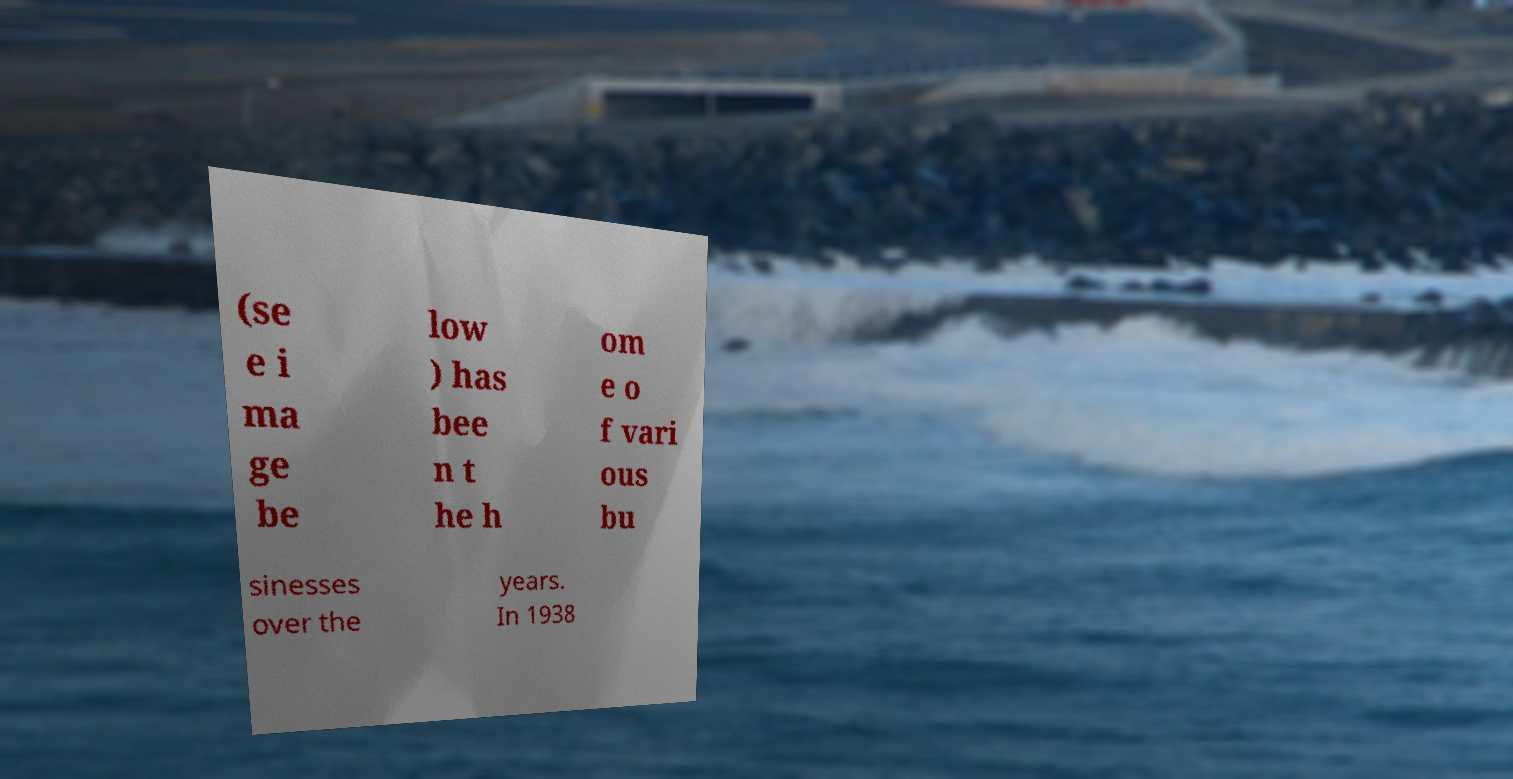There's text embedded in this image that I need extracted. Can you transcribe it verbatim? (se e i ma ge be low ) has bee n t he h om e o f vari ous bu sinesses over the years. In 1938 